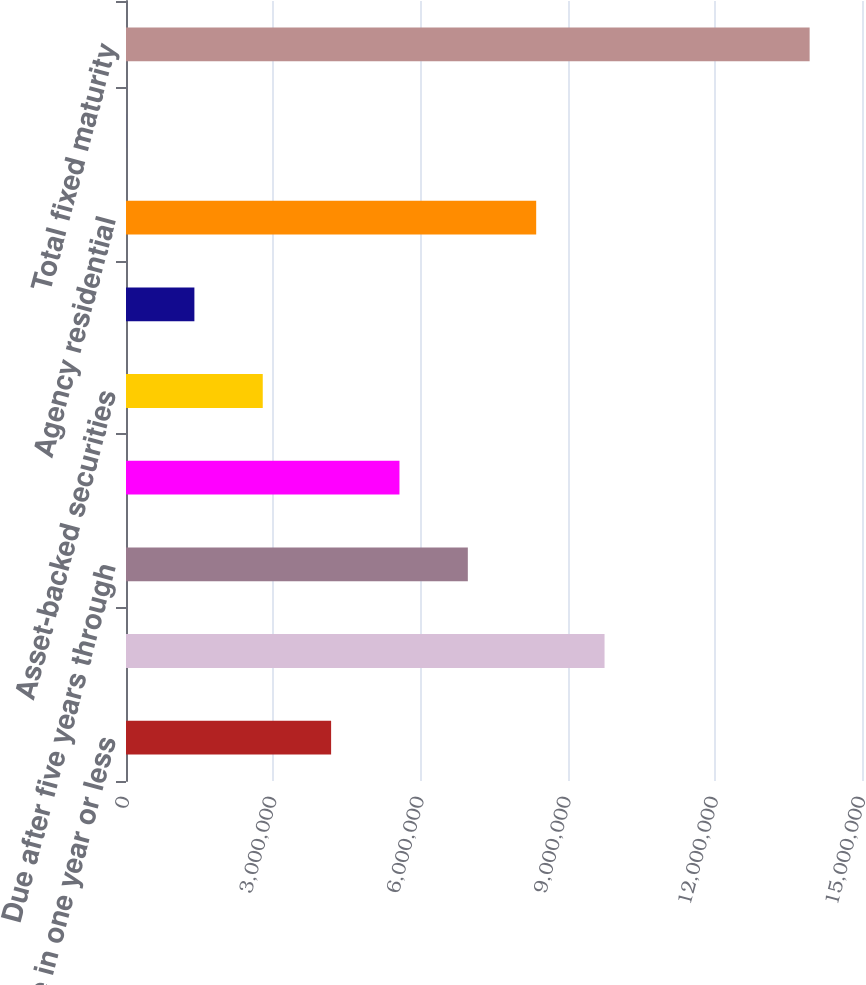<chart> <loc_0><loc_0><loc_500><loc_500><bar_chart><fcel>Due in one year or less<fcel>Due after one year through<fcel>Due after five years through<fcel>Due after ten years<fcel>Asset-backed securities<fcel>Commercial<fcel>Agency residential<fcel>Non-agency residential<fcel>Total fixed maturity<nl><fcel>4.18023e+06<fcel>9.75302e+06<fcel>6.96663e+06<fcel>5.57343e+06<fcel>2.78704e+06<fcel>1.39384e+06<fcel>8.35982e+06<fcel>642<fcel>1.39326e+07<nl></chart> 